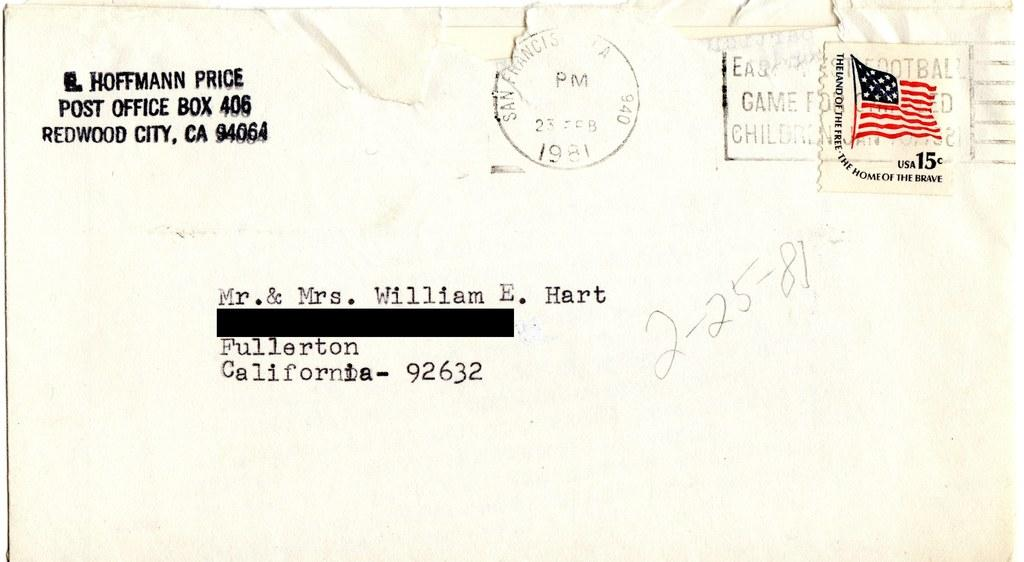<image>
Render a clear and concise summary of the photo. The envelope is addressed to Mr. & Mrs. William E. Hart and was postmarked 1981. 